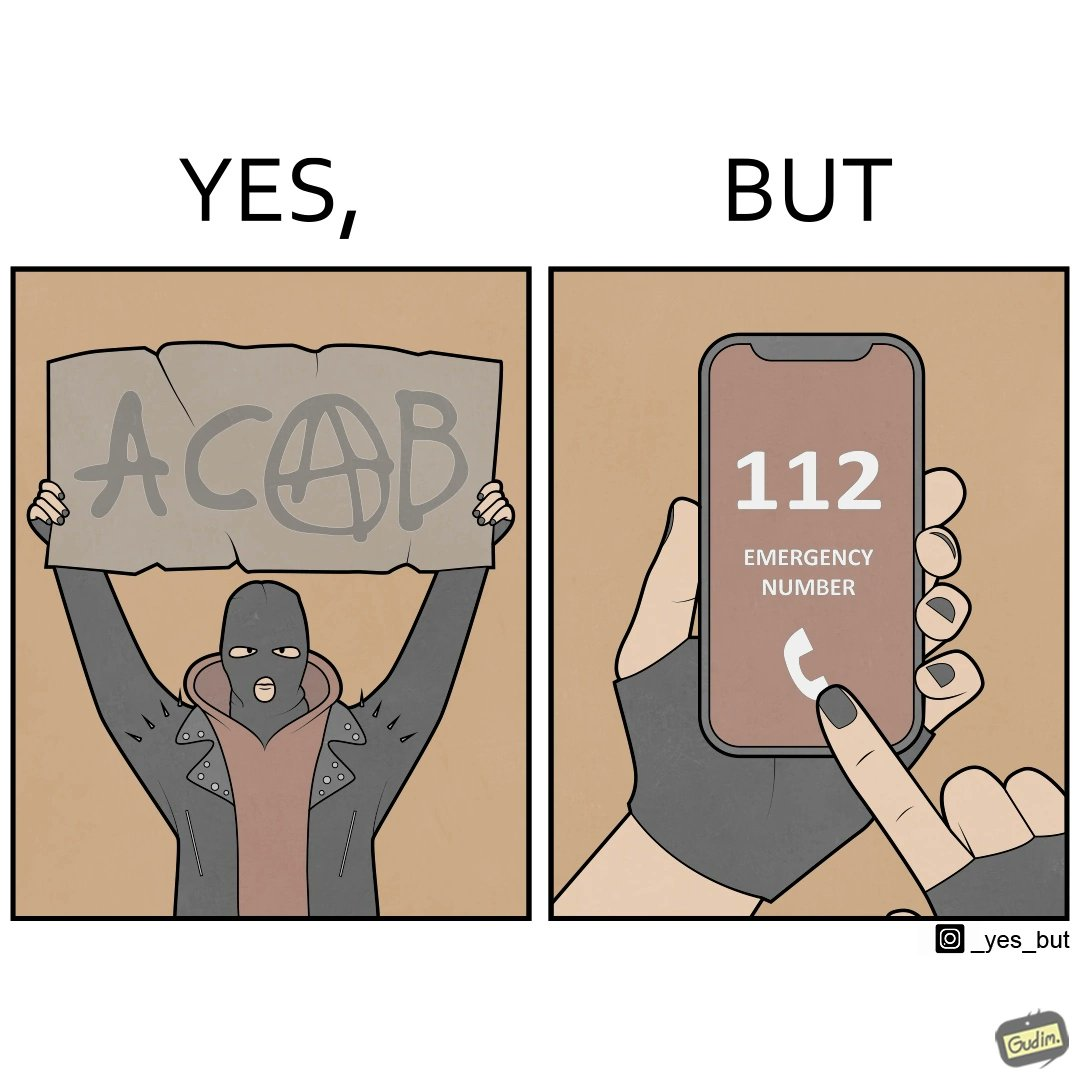What makes this image funny or satirical? This is funny because on the one hand this person is rebelling against cops (slogan being All Cops Are Bad - ACAB), but on the other hand they are also calling the cops for help. 